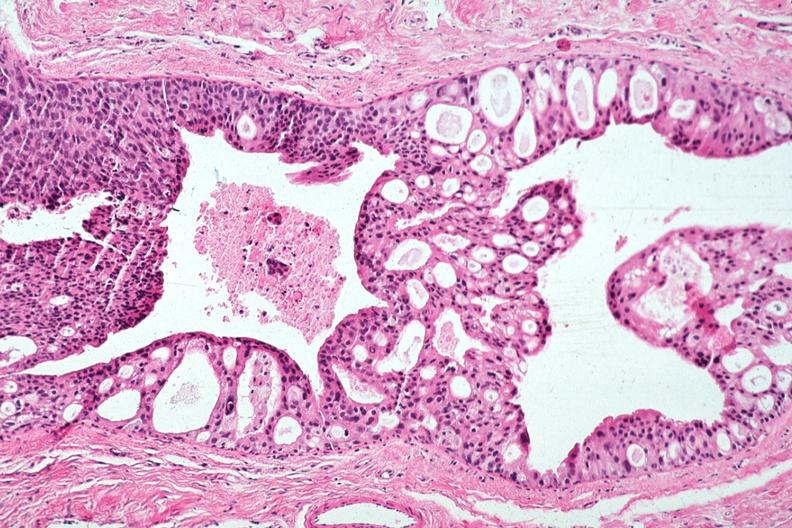what does this image show?
Answer the question using a single word or phrase. Excellent cribriform pattern all tumor in duct 